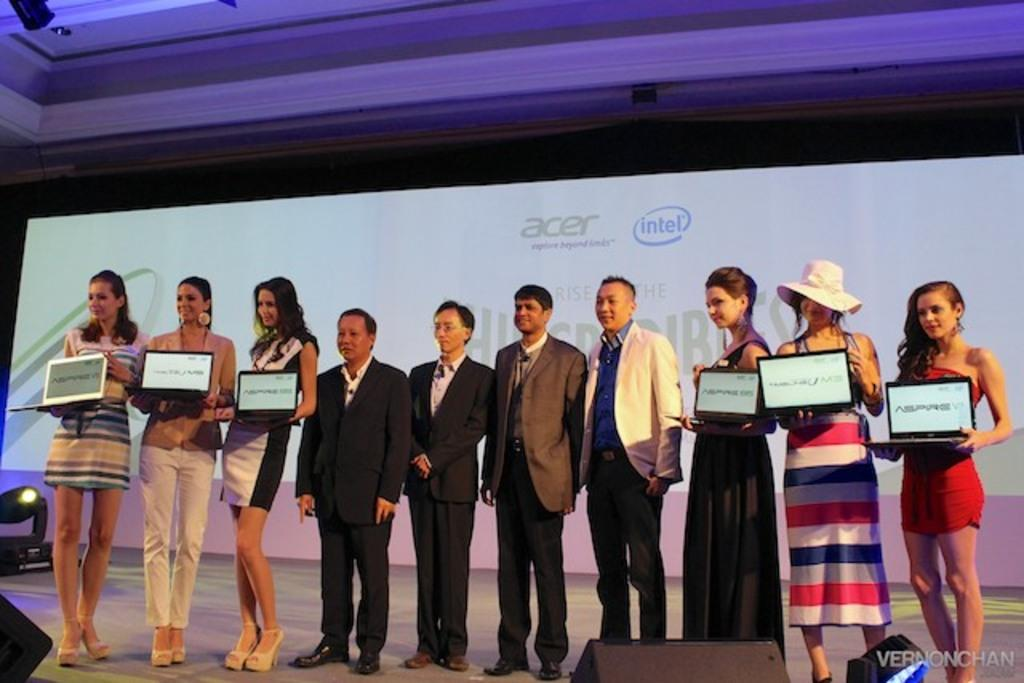What are the people in the image doing? The people in the image are standing and holding laptops. What can be seen in the background of the image? There is a banner in the background of the image. Is there any source of light visible in the image? Yes, there is a light visible in the image. Can you describe the clothing or accessories of any person in the image? A girl is wearing a cap in the image. What type of quicksand can be seen in the image? There is no quicksand present in the image. How does the girl's haircut look in the image? The provided facts do not mention the girl's haircut, so it cannot be determined from the image. 